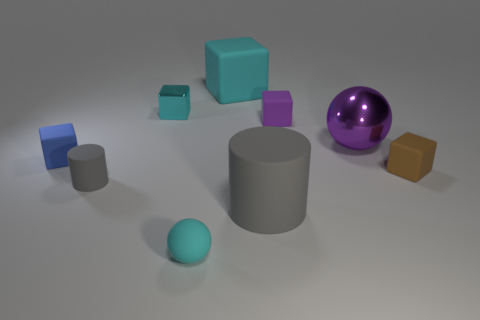Can you describe the different textures that the objects seem to have? The objects showcase a variety of textures. The cyan block and the small blue block exhibit a metallic sheen, suggesting a smooth and reflective surface. The purple ball has a glossy finish that is highly reflective, unlike the muted, non-reflective matte finish of the grey cylinder and the smaller spheres. The brown cube appears to have a slightly rough, perhaps plastic-like texture. 